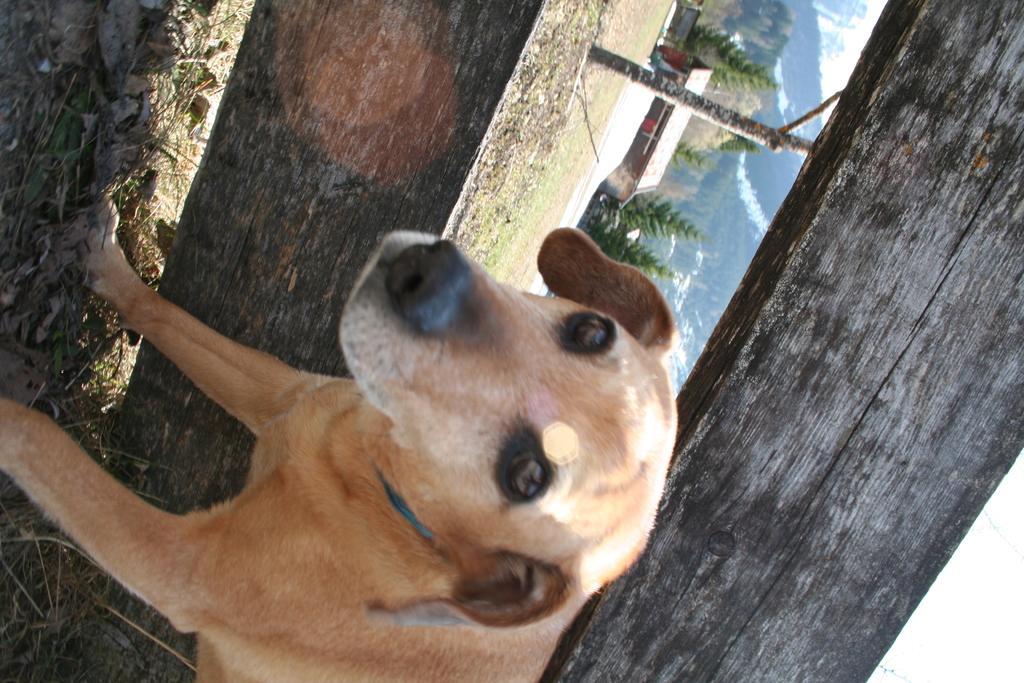Can you describe this image briefly? In this image we can see a dog. Behind the dog there is a wooden fencing. In the back there are trees, hills and a building. 